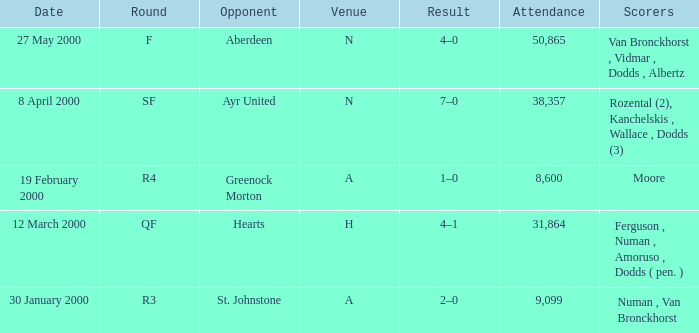Could you help me parse every detail presented in this table? {'header': ['Date', 'Round', 'Opponent', 'Venue', 'Result', 'Attendance', 'Scorers'], 'rows': [['27 May 2000', 'F', 'Aberdeen', 'N', '4–0', '50,865', 'Van Bronckhorst , Vidmar , Dodds , Albertz'], ['8 April 2000', 'SF', 'Ayr United', 'N', '7–0', '38,357', 'Rozental (2), Kanchelskis , Wallace , Dodds (3)'], ['19 February 2000', 'R4', 'Greenock Morton', 'A', '1–0', '8,600', 'Moore'], ['12 March 2000', 'QF', 'Hearts', 'H', '4–1', '31,864', 'Ferguson , Numan , Amoruso , Dodds ( pen. )'], ['30 January 2000', 'R3', 'St. Johnstone', 'A', '2–0', '9,099', 'Numan , Van Bronckhorst']]} Who was on 12 March 2000? Ferguson , Numan , Amoruso , Dodds ( pen. ). 